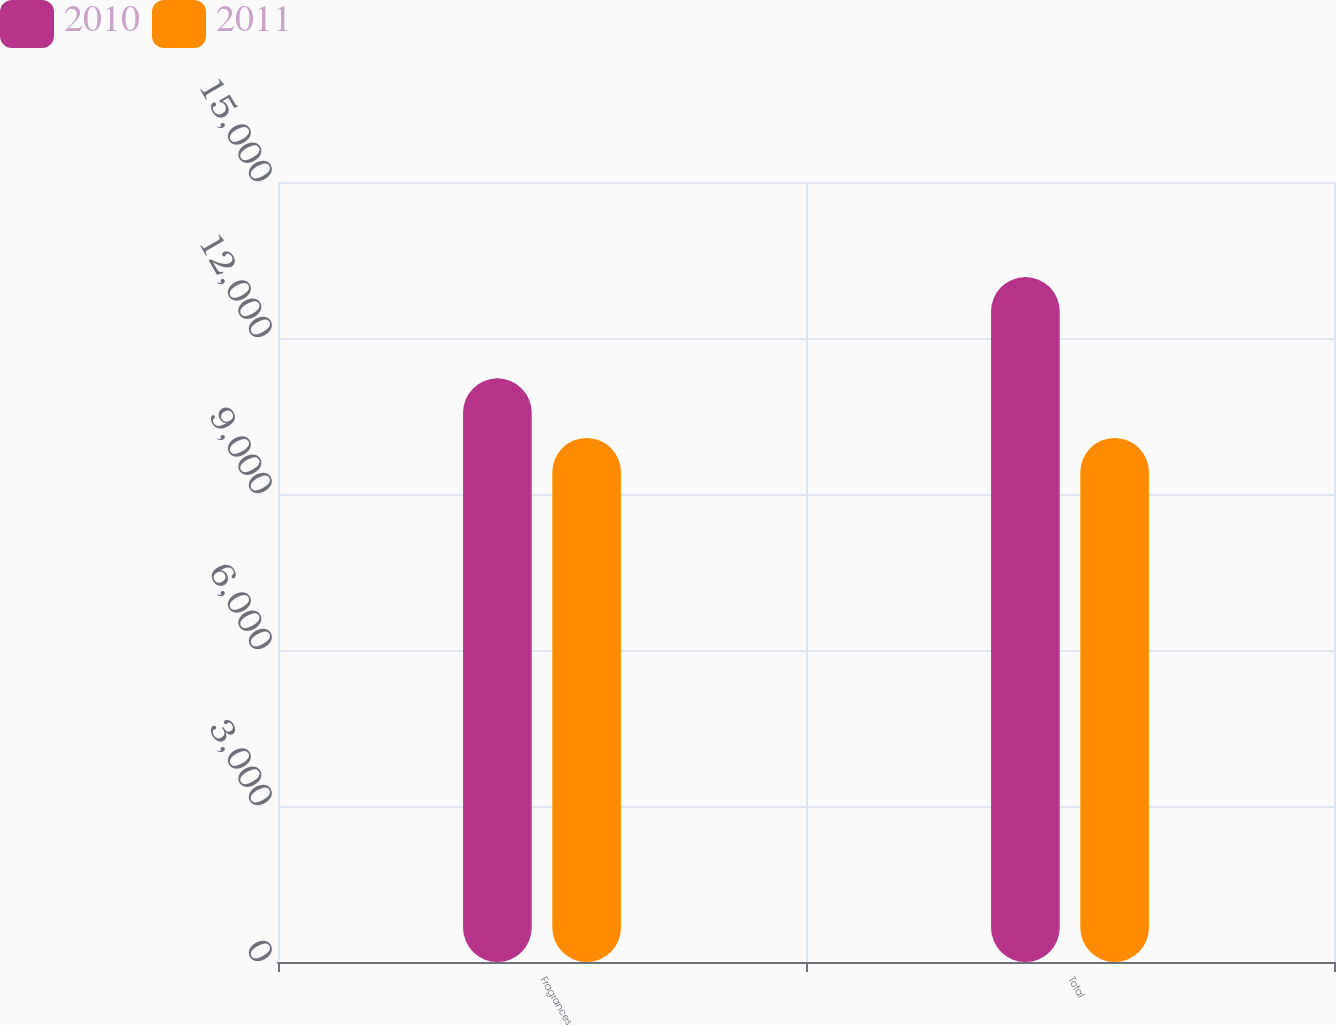Convert chart. <chart><loc_0><loc_0><loc_500><loc_500><stacked_bar_chart><ecel><fcel>Fragrances<fcel>Total<nl><fcel>2010<fcel>11224<fcel>13172<nl><fcel>2011<fcel>10077<fcel>10077<nl></chart> 